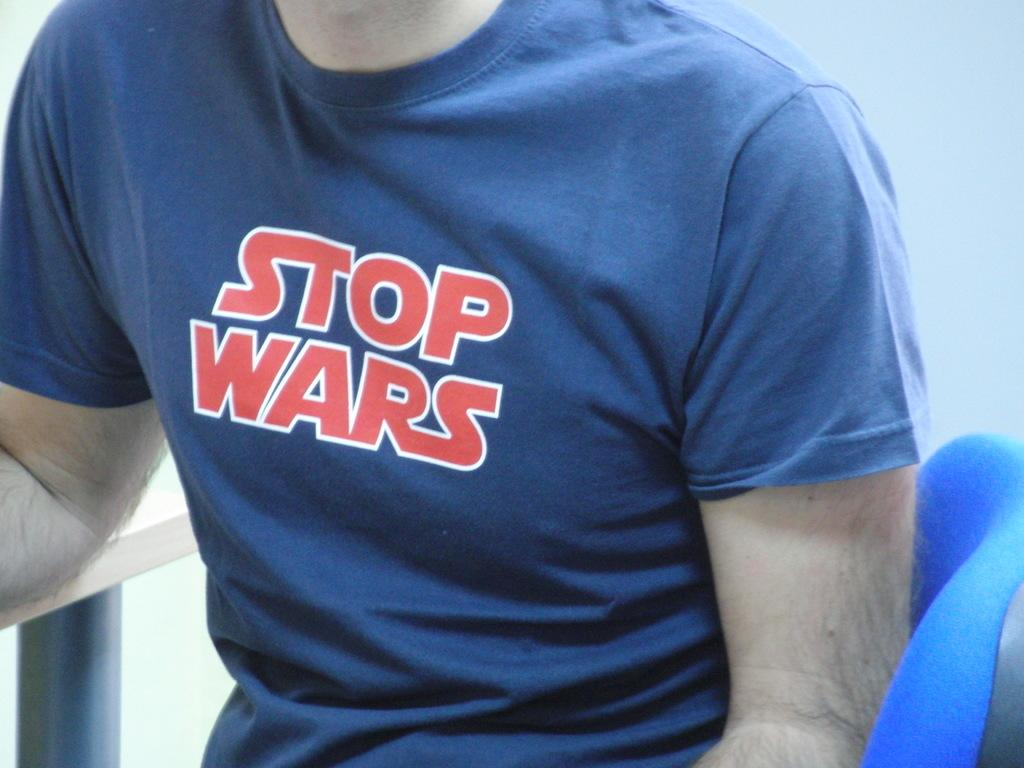Provide a one-sentence caption for the provided image. A male wearing a blue shirt that says stop wars. 